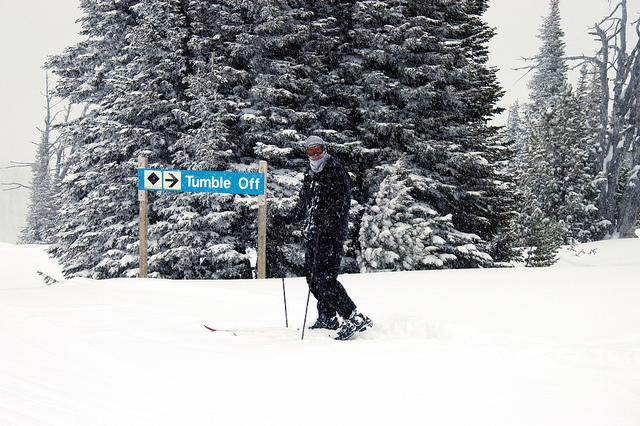Where is the arrow pointing?
Concise answer only. Right. What color is the person's outfit?
Be succinct. Black. Is tumble on?
Keep it brief. No. 